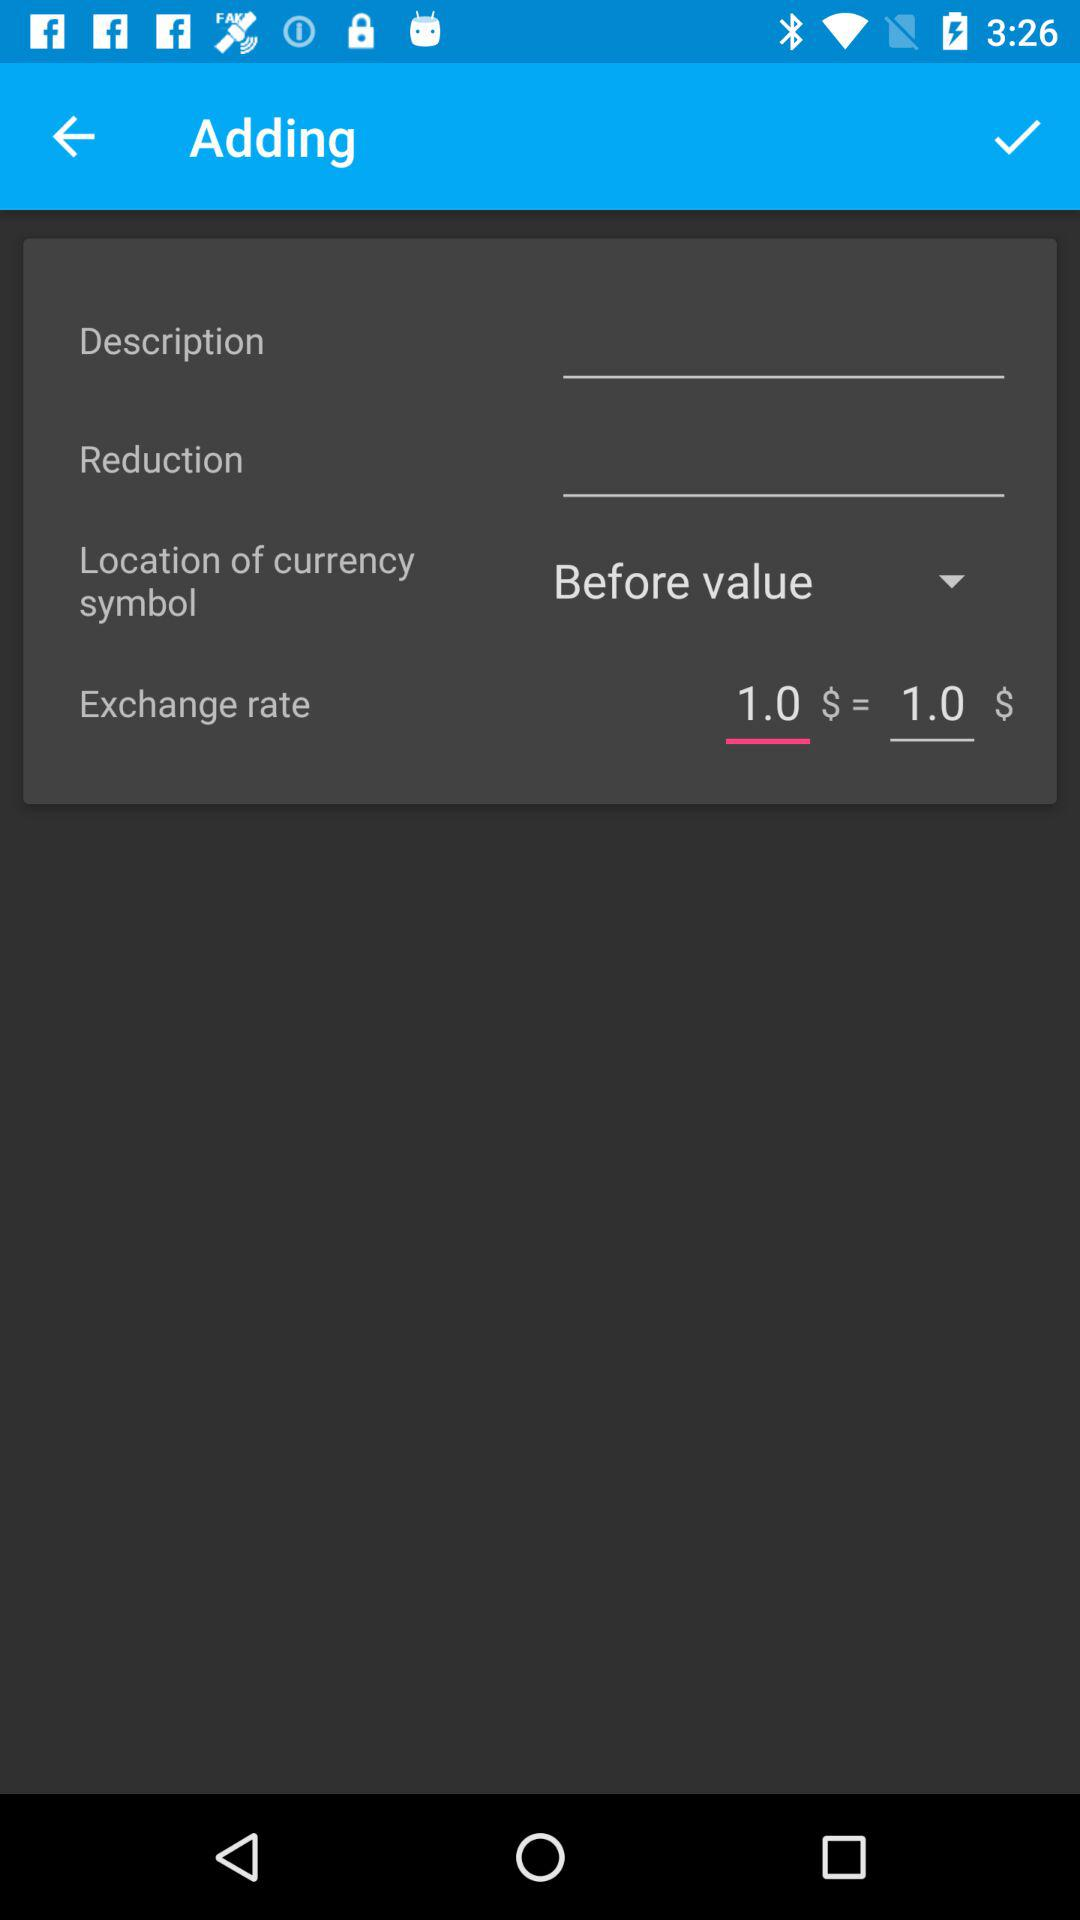What is the exchange rate for $1.0? The exchange rate is $1. 